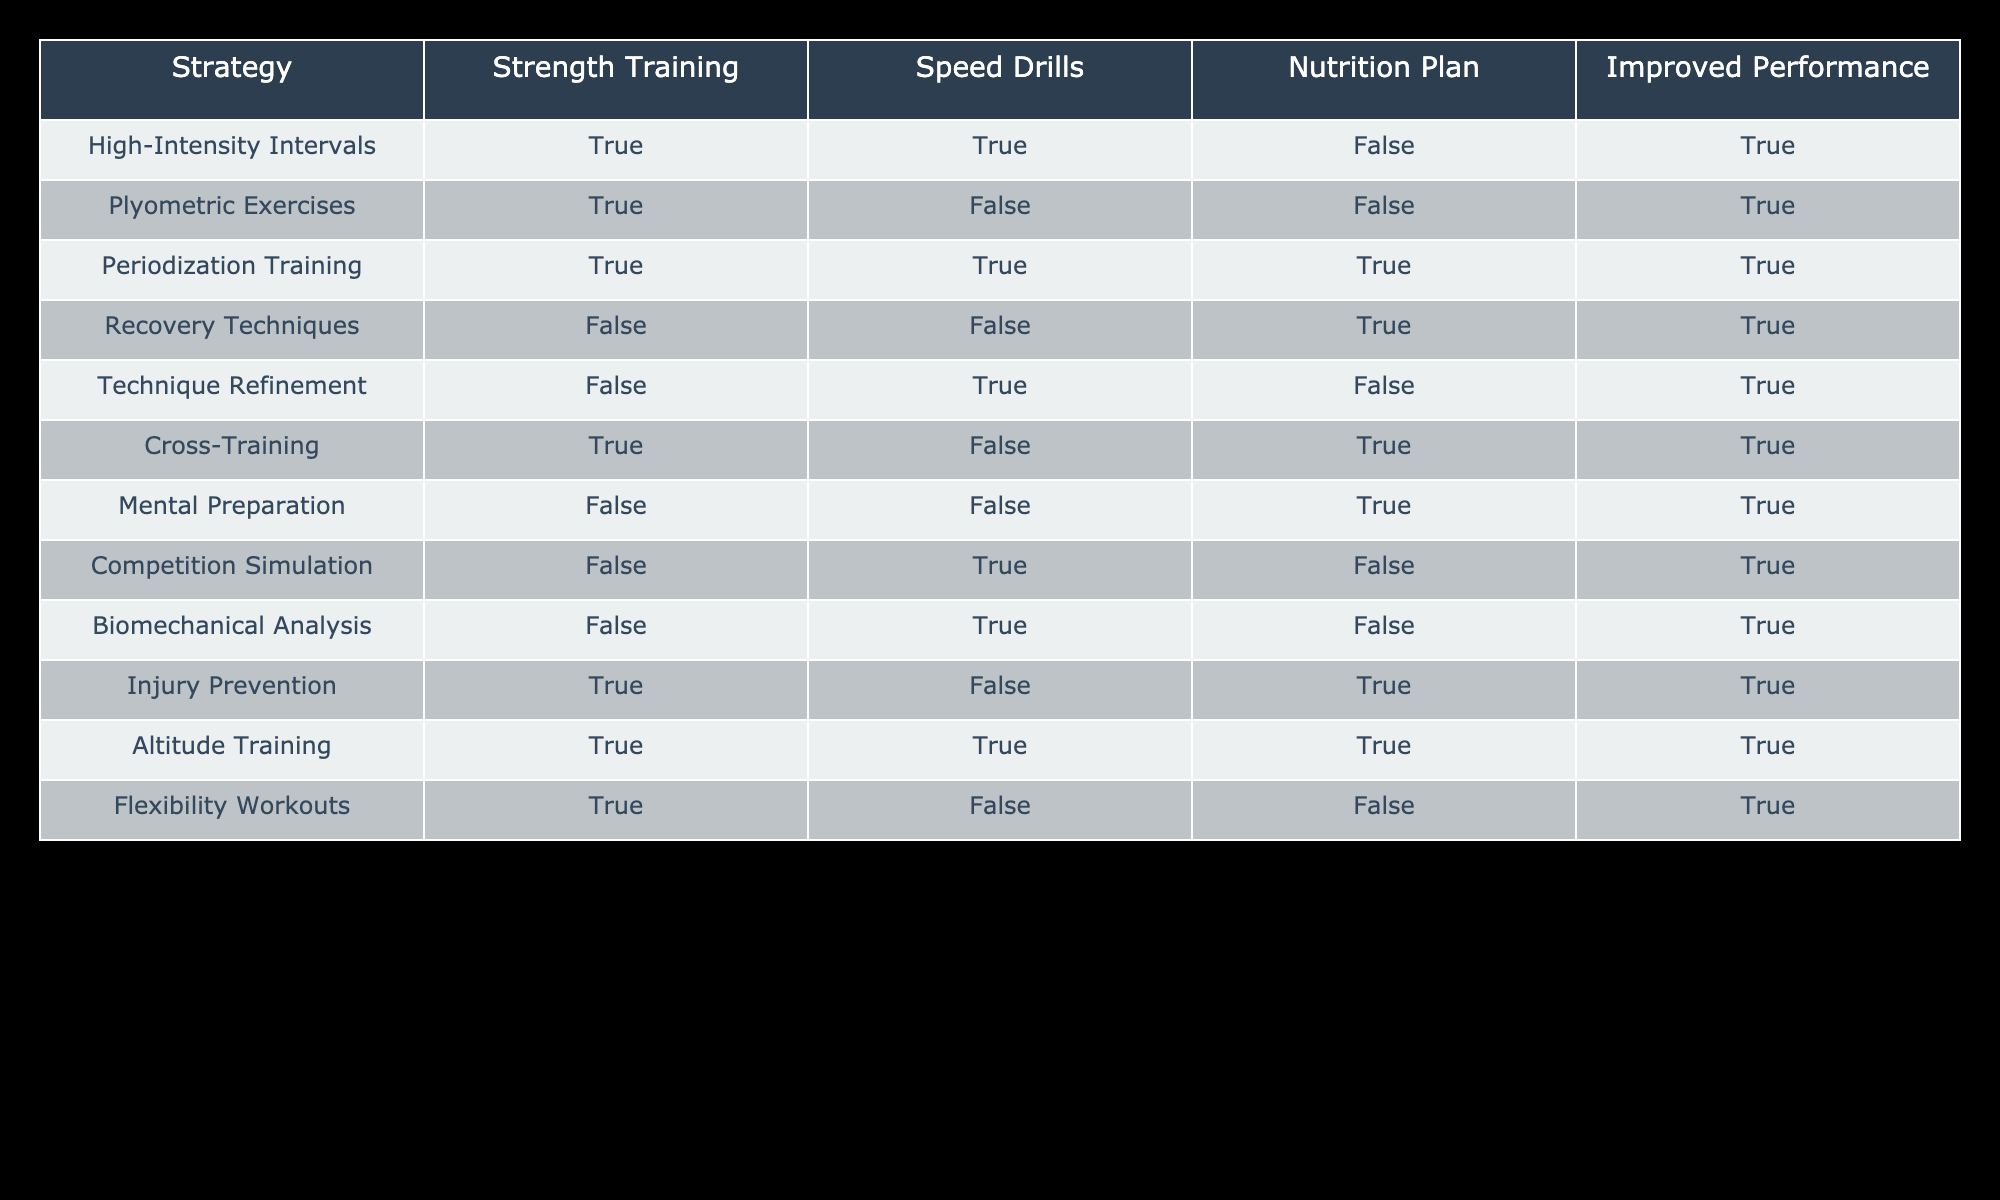What strategies involve strength training? To find the strategies that involve strength training, we check the 'Strength Training' column for entries marked as TRUE. The strategies with TRUE in this column are: High-Intensity Intervals, Plyometric Exercises, Periodization Training, Cross-Training, Injury Prevention, Altitude Training, and Flexibility Workouts.
Answer: High-Intensity Intervals, Plyometric Exercises, Periodization Training, Cross-Training, Injury Prevention, Altitude Training, Flexibility Workouts Is there a strategy that combines speed drills and a nutrition plan? We need to find strategies that have both Speed Drills and Nutrition Plan marked as TRUE. Scanning through the table, only the Periodization Training and Altitude Training strategies meet this criterion.
Answer: Yes, Periodization Training and Altitude Training How many strategies improve performance and involve speed drills? To answer this, we check for strategies where the ‘Improved Performance’ column is TRUE, along with the ‘Speed Drills’ column also being TRUE. The strategies that meet these criteria are High-Intensity Intervals, Periodization Training, and Technique Refinement. There are three such strategies.
Answer: Three Are there any strategies that do not require nutrition plans yet improve performance? We look for strategies where the ‘Nutrition Plan’ is FALSE and ‘Improved Performance’ is TRUE. Checking the table, the strategies that meet this condition are High-Intensity Intervals, Plyometric Exercises, Recovery Techniques, Technique Refinement, Cross-Training, and Injury Prevention. Therefore, there are six strategies in total.
Answer: Six What is the total number of strategies that involve both high-intensity intervals and speed drills? We observe that High-Intensity Intervals is the only strategy that involves both high-intensity intervals and speed drills. Therefore, the total count is one.
Answer: One Which strategy with recovery techniques also improves performance? We check the Recovery Techniques strategy in the table, which indicates TRUE for ‘Improved Performance’. The Recovery Techniques strategy indeed improves performance.
Answer: Recovery Techniques What is the average number of strategies that involve speed drills? First, count the total strategies that involve speed drills, which are: High-Intensity Intervals, Technique Refinement, Competition Simulation, and Biomechanical Analysis, totaling four strategies. The total number of strategies is 12. Thus, the average is 4/12, simplified to 1/3.
Answer: One-third Which strategy uniquely focuses on technique refinement with no strength training included? The Technique Refinement strategy is checked; it shows FALSE in the Strength Training column and TRUE in the Speed Drills column. Hence, it uniquely focuses on technique refinement without strength training.
Answer: Technique Refinement 